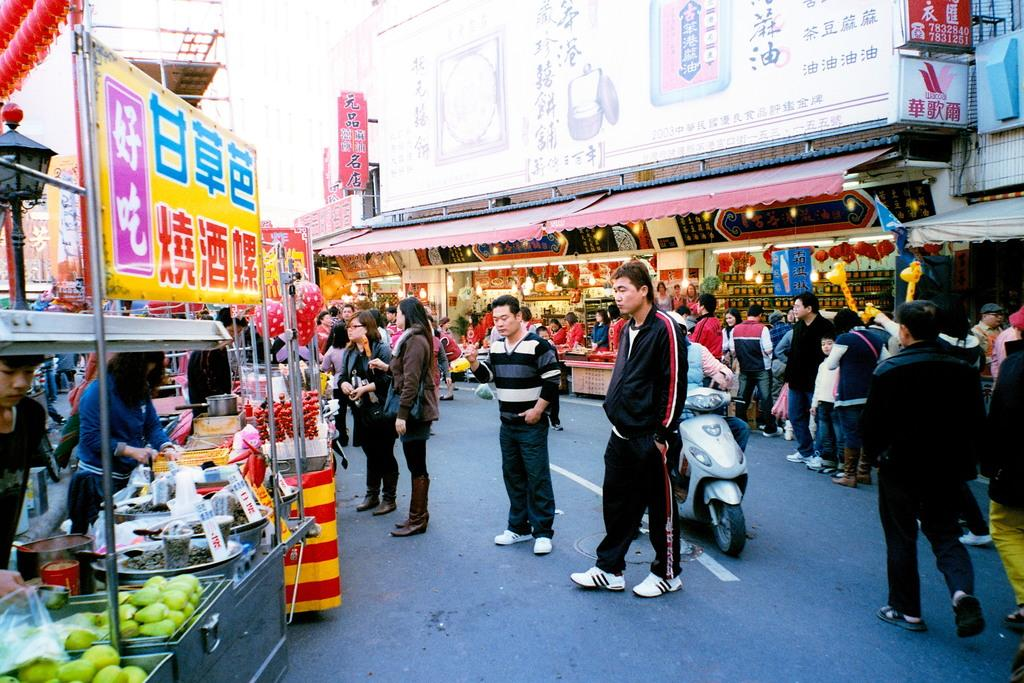What is happening on the road in the image? There is a group of people on the road, and one person is on a bike. What type of structures can be seen in the image? There are buildings and shops visible in the image. What items are related to food in the image? Food items and bowls are present in the image. What type of signage is visible in the image? Posters are visible in the image. What is the tall, vertical object in the image? There is a pole in the image. What other objects can be seen in the image? There are other objects in the image, but their specific details are not mentioned in the provided facts. Where is the nest of the ray located in the image? There is no nest or ray present in the image. What type of fuel is being used by the coal-powered bike in the image? There is no bike powered by coal in the image. 